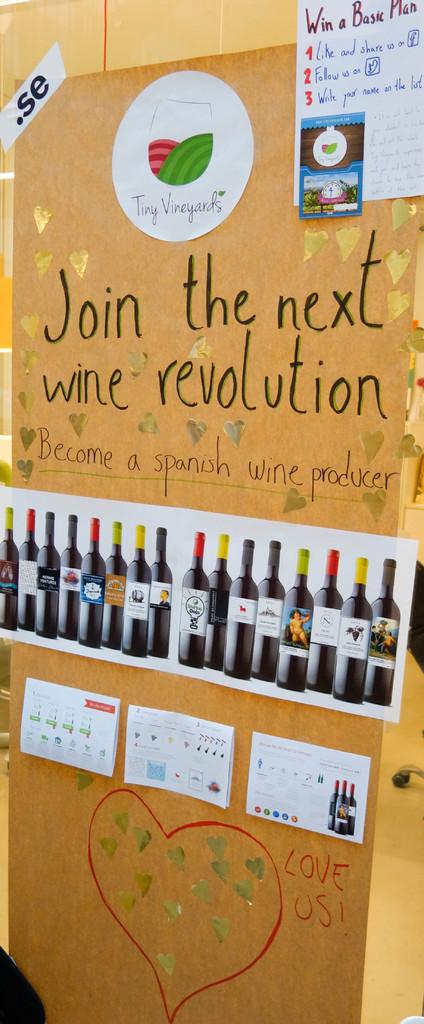What revolution is mentioned?
Your response must be concise. Wine. What does the poster ask us to do?
Offer a very short reply. Join the next wine revolution. 